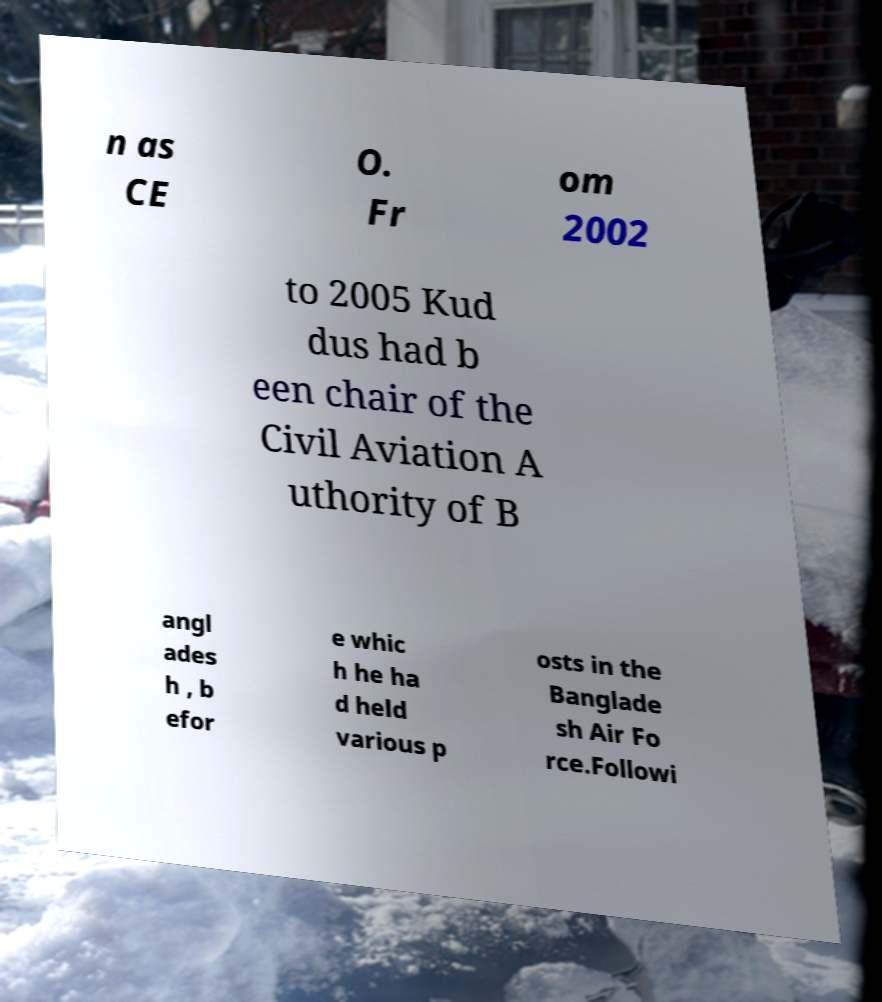I need the written content from this picture converted into text. Can you do that? n as CE O. Fr om 2002 to 2005 Kud dus had b een chair of the Civil Aviation A uthority of B angl ades h , b efor e whic h he ha d held various p osts in the Banglade sh Air Fo rce.Followi 